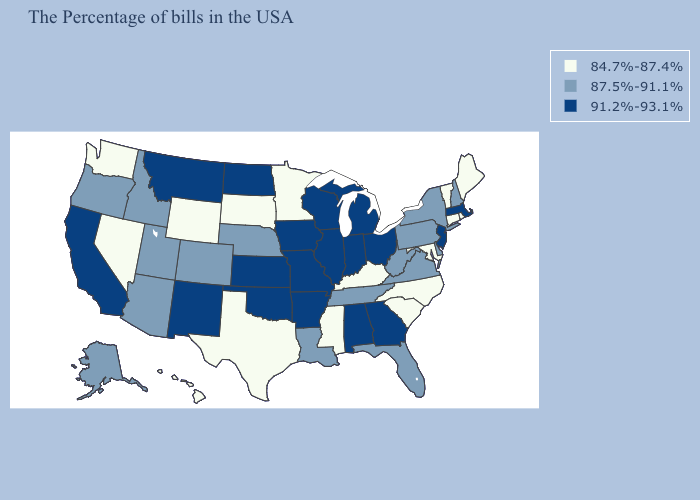Name the states that have a value in the range 84.7%-87.4%?
Concise answer only. Maine, Rhode Island, Vermont, Connecticut, Maryland, North Carolina, South Carolina, Kentucky, Mississippi, Minnesota, Texas, South Dakota, Wyoming, Nevada, Washington, Hawaii. Does Pennsylvania have the lowest value in the USA?
Be succinct. No. Name the states that have a value in the range 91.2%-93.1%?
Short answer required. Massachusetts, New Jersey, Ohio, Georgia, Michigan, Indiana, Alabama, Wisconsin, Illinois, Missouri, Arkansas, Iowa, Kansas, Oklahoma, North Dakota, New Mexico, Montana, California. What is the value of Minnesota?
Short answer required. 84.7%-87.4%. Which states hav the highest value in the South?
Answer briefly. Georgia, Alabama, Arkansas, Oklahoma. Which states hav the highest value in the Northeast?
Concise answer only. Massachusetts, New Jersey. Does Indiana have a higher value than North Dakota?
Write a very short answer. No. Name the states that have a value in the range 87.5%-91.1%?
Be succinct. New Hampshire, New York, Delaware, Pennsylvania, Virginia, West Virginia, Florida, Tennessee, Louisiana, Nebraska, Colorado, Utah, Arizona, Idaho, Oregon, Alaska. Does Maine have the lowest value in the Northeast?
Write a very short answer. Yes. Name the states that have a value in the range 91.2%-93.1%?
Short answer required. Massachusetts, New Jersey, Ohio, Georgia, Michigan, Indiana, Alabama, Wisconsin, Illinois, Missouri, Arkansas, Iowa, Kansas, Oklahoma, North Dakota, New Mexico, Montana, California. What is the value of Minnesota?
Concise answer only. 84.7%-87.4%. Does North Dakota have the lowest value in the USA?
Answer briefly. No. Which states have the lowest value in the MidWest?
Quick response, please. Minnesota, South Dakota. Name the states that have a value in the range 91.2%-93.1%?
Give a very brief answer. Massachusetts, New Jersey, Ohio, Georgia, Michigan, Indiana, Alabama, Wisconsin, Illinois, Missouri, Arkansas, Iowa, Kansas, Oklahoma, North Dakota, New Mexico, Montana, California. What is the value of Wisconsin?
Give a very brief answer. 91.2%-93.1%. 